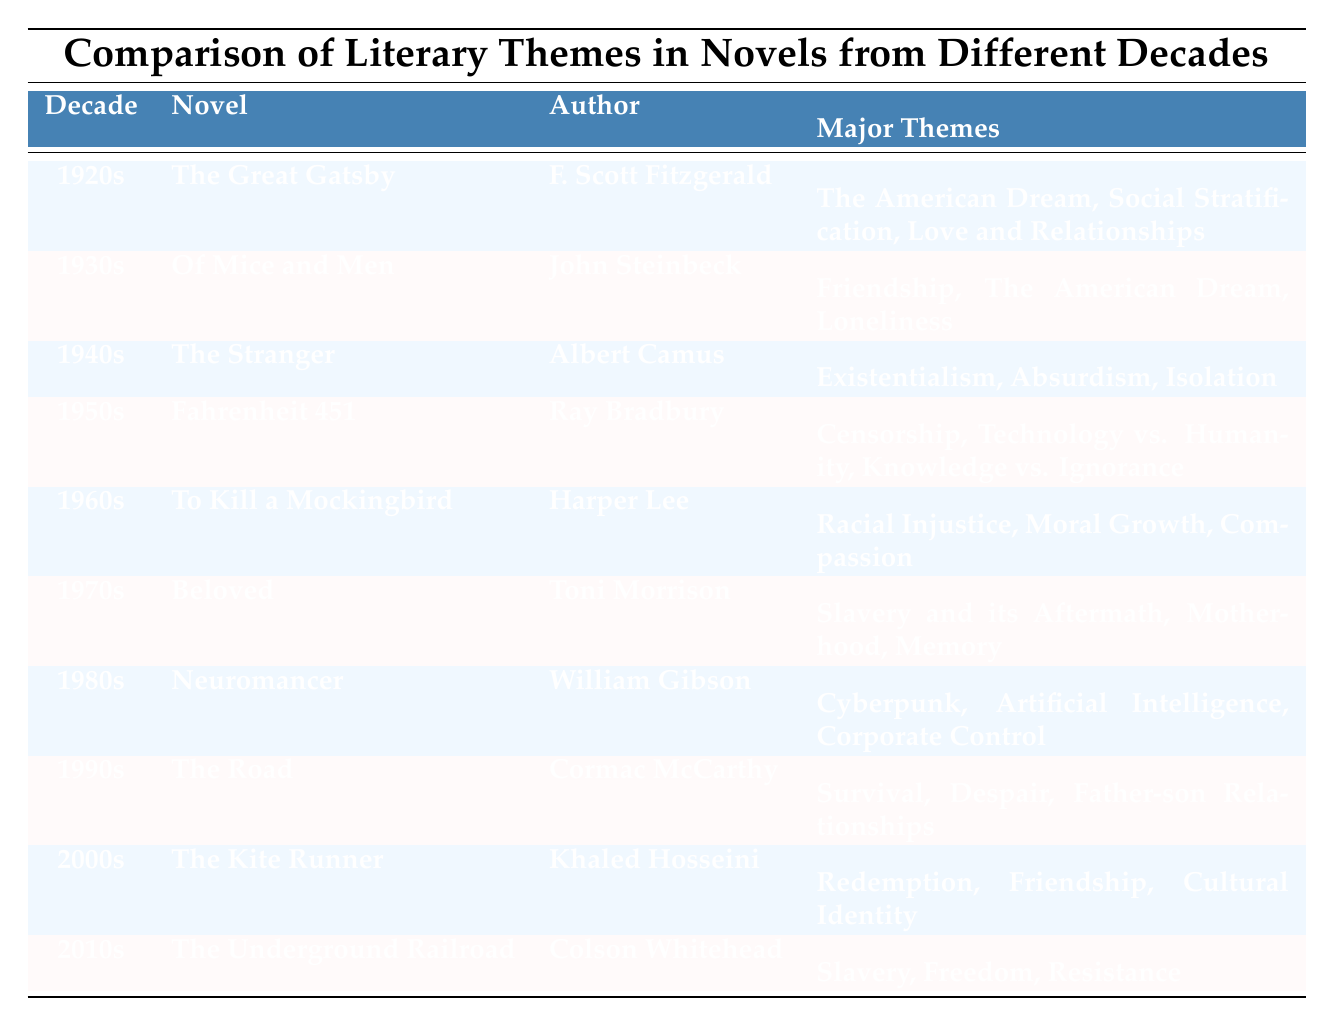What major themes are explored in the novel "Beloved"? "Beloved" is listed in the table under the 1970s decade. Its major themes are explicitly mentioned as "Slavery and its Aftermath, Motherhood, Memory."
Answer: Slavery and its Aftermath, Motherhood, Memory Which author wrote a novel that deals with the theme of "Existentialism"? The table indicates that "The Stranger," written by Albert Camus in the 1940s, deals with the theme of "Existentialism."
Answer: Albert Camus Is "To Kill a Mockingbird" associated with the theme of "Censorship"? The table shows that "To Kill a Mockingbird," written by Harper Lee in the 1960s, is associated with the themes of "Racial Injustice, Moral Growth, Compassion," but "Censorship" is not one of them.
Answer: No How many novels from the 2000s focus on themes of "Friendship"? In the table, "The Kite Runner" by Khaled Hosseini is the only novel listed from the 2000s, and it has "Friendship" as one of its major themes. Therefore, the count is one.
Answer: 1 Which decade features a novel with themes related to "Cyberpunk"? The table indicates that "Neuromancer," written by William Gibson, features major themes of "Cyberpunk," and it is listed under the 1980s.
Answer: 1980s How many total major themes are mentioned for the novel "Fahrenheit 451"? "Fahrenheit 451," authored by Ray Bradbury in the 1950s, has three major themes listed: "Censorship, Technology vs. Humanity, Knowledge vs. Ignorance." Therefore, the total count is three.
Answer: 3 Are any novels listed that discuss "Freedom"? "The Underground Railroad" by Colson Whitehead, listed in the 2010s, explicitly discusses the theme of "Freedom" among others. Therefore, the answer is yes.
Answer: Yes What is the difference in the number of major themes between the novels "The Great Gatsby" and "The Road"? "The Great Gatsby" has three major themes, while "The Road" has three major themes as well. The difference in the count is 0 since both have the same number of themes.
Answer: 0 